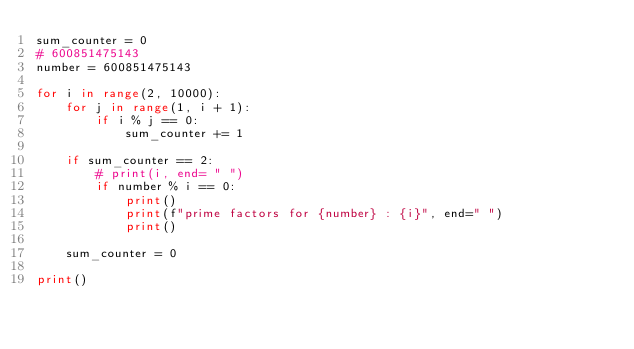<code> <loc_0><loc_0><loc_500><loc_500><_Python_>sum_counter = 0
# 600851475143
number = 600851475143

for i in range(2, 10000):
    for j in range(1, i + 1):
        if i % j == 0:
            sum_counter += 1

    if sum_counter == 2:
        # print(i, end= " ")
        if number % i == 0:
            print()
            print(f"prime factors for {number} : {i}", end=" ")
            print()

    sum_counter = 0

print()
</code> 